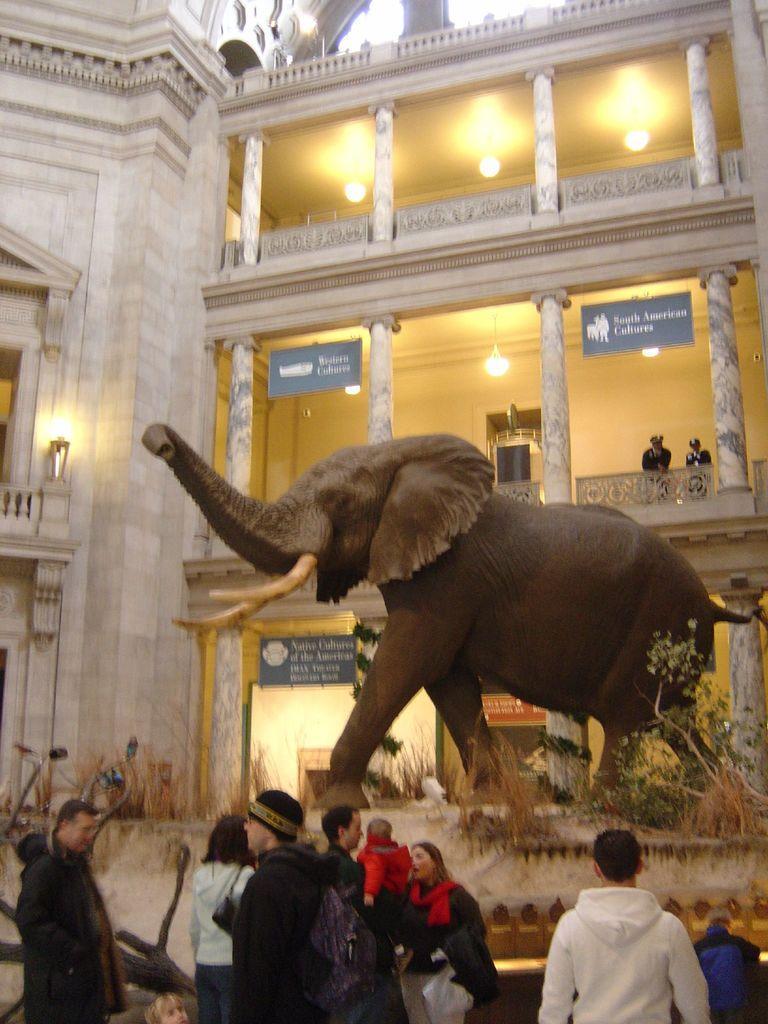Please provide a concise description of this image. In this image in the front there are persons. In the center there is dry grass and there are dry plants and there is statue of an elephant. In the background there is a building and there are persons standing in the balcony and there are boards with some text written on it and there are lights. 